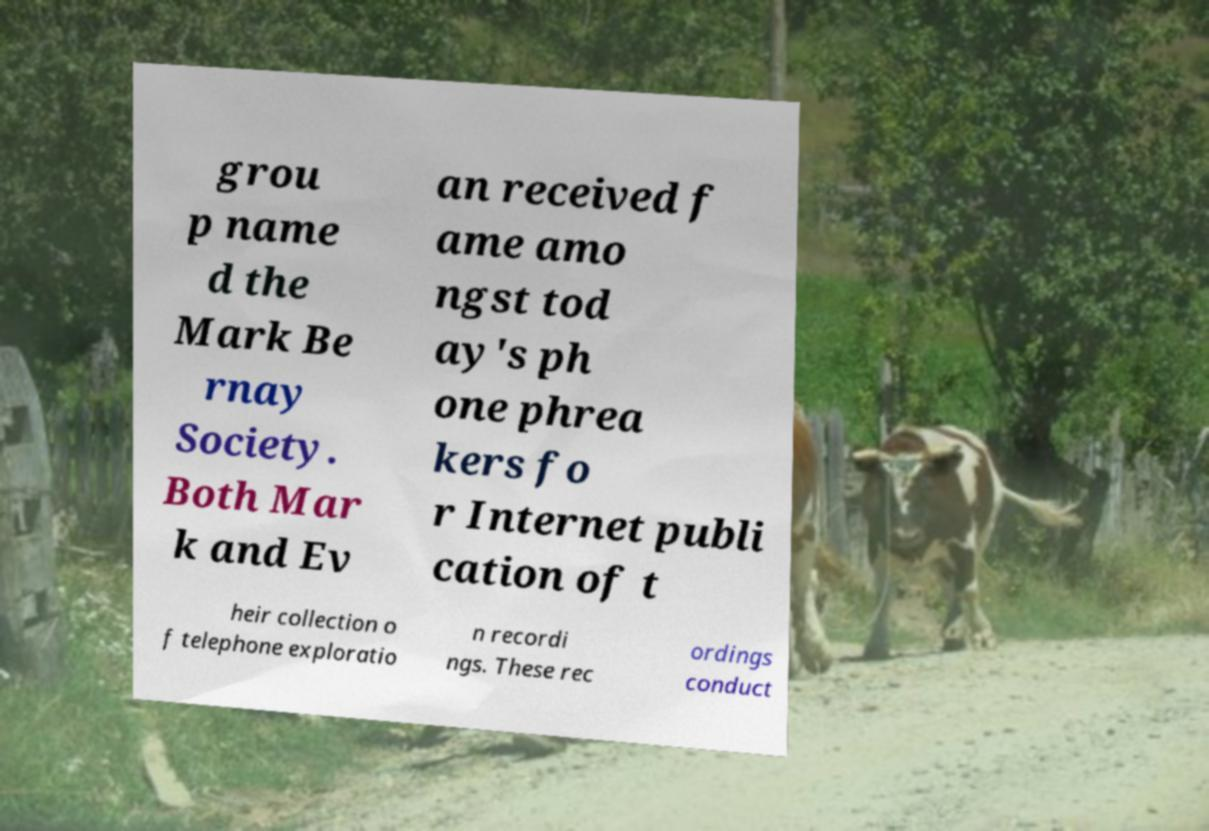Please identify and transcribe the text found in this image. grou p name d the Mark Be rnay Society. Both Mar k and Ev an received f ame amo ngst tod ay's ph one phrea kers fo r Internet publi cation of t heir collection o f telephone exploratio n recordi ngs. These rec ordings conduct 